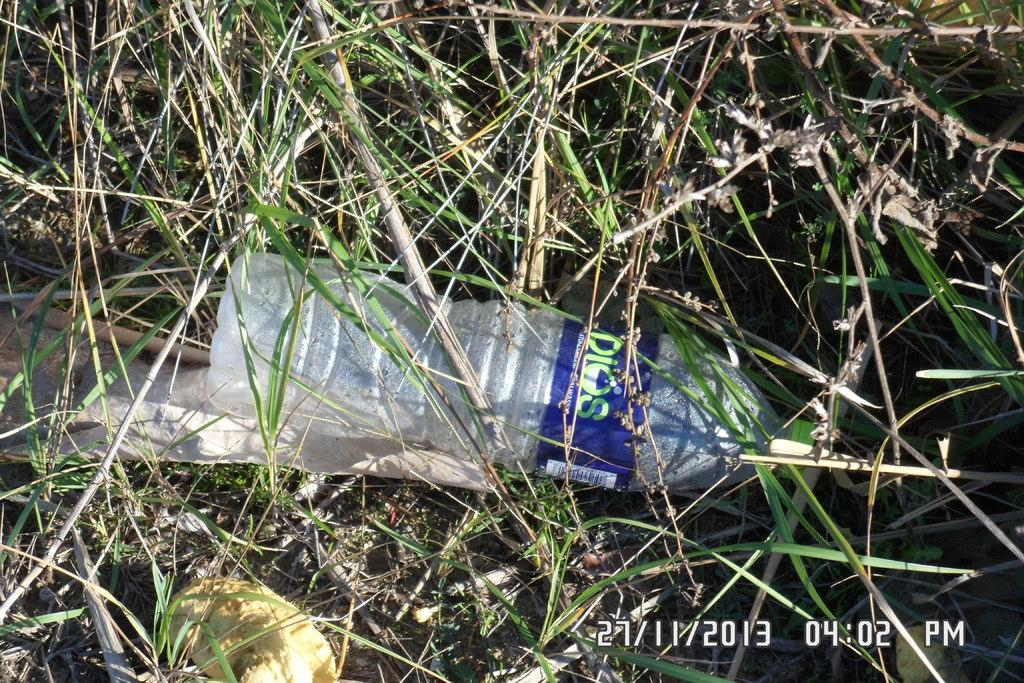What object can be seen in the image? There is a bottle in the image. What type of vegetation is present in the image? There is grass in the image. How does the drain affect the grass in the image? There is no drain present in the image, so it cannot affect the grass. 